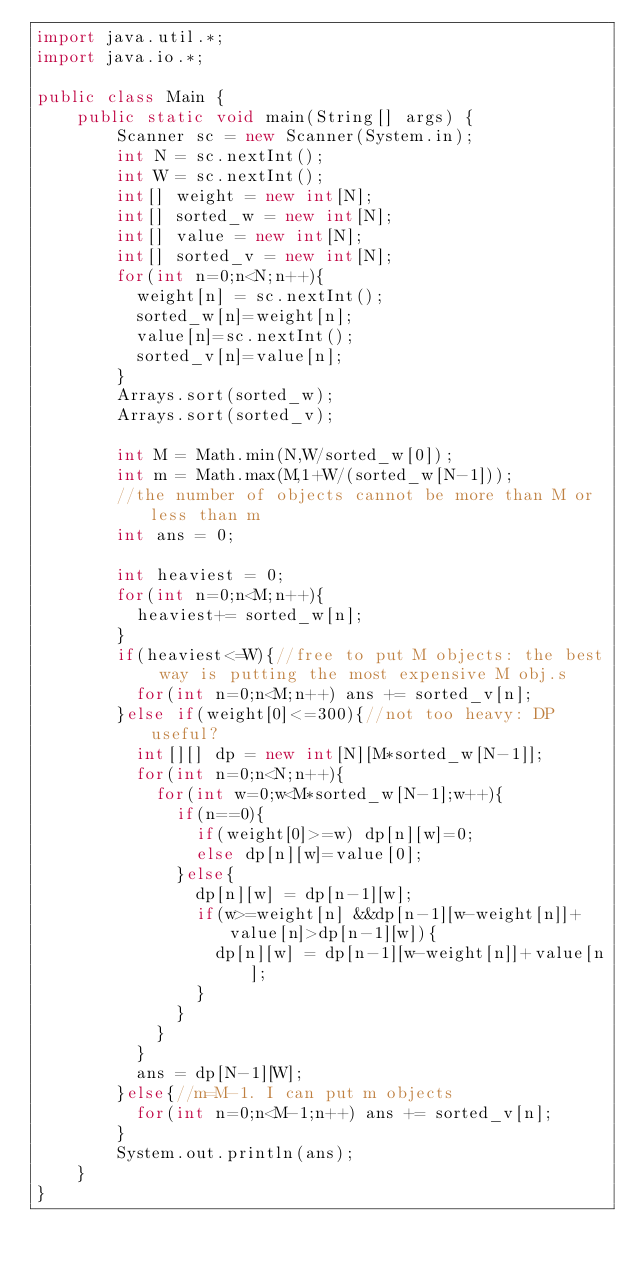Convert code to text. <code><loc_0><loc_0><loc_500><loc_500><_Java_>import java.util.*;
import java.io.*;

public class Main {
    public static void main(String[] args) {
        Scanner sc = new Scanner(System.in);
        int N = sc.nextInt();
        int W = sc.nextInt();
        int[] weight = new int[N];
        int[] sorted_w = new int[N];
        int[] value = new int[N];
        int[] sorted_v = new int[N];
        for(int n=0;n<N;n++){
        	weight[n] = sc.nextInt();
        	sorted_w[n]=weight[n];
        	value[n]=sc.nextInt();
        	sorted_v[n]=value[n];
        }
        Arrays.sort(sorted_w);
        Arrays.sort(sorted_v);
        
        int M = Math.min(N,W/sorted_w[0]);
        int m = Math.max(M,1+W/(sorted_w[N-1]));
        //the number of objects cannot be more than M or less than m
        int ans = 0;
        
        int heaviest = 0;
        for(int n=0;n<M;n++){
        	heaviest+= sorted_w[n];
        }
        if(heaviest<=W){//free to put M objects: the best way is putting the most expensive M obj.s
        	for(int n=0;n<M;n++) ans += sorted_v[n];
        }else if(weight[0]<=300){//not too heavy: DP useful?
        	int[][] dp = new int[N][M*sorted_w[N-1]];
        	for(int n=0;n<N;n++){
        		for(int w=0;w<M*sorted_w[N-1];w++){
        			if(n==0){
        				if(weight[0]>=w) dp[n][w]=0;
        				else dp[n][w]=value[0];
        			}else{
        				dp[n][w] = dp[n-1][w];
        				if(w>=weight[n] &&dp[n-1][w-weight[n]]+value[n]>dp[n-1][w]){
        					dp[n][w] = dp[n-1][w-weight[n]]+value[n];
        				}
        			}
        		}
        	}
        	ans = dp[N-1][W];
        }else{//m=M-1. I can put m objects
        	for(int n=0;n<M-1;n++) ans += sorted_v[n];
        }
        System.out.println(ans);
    }
}</code> 